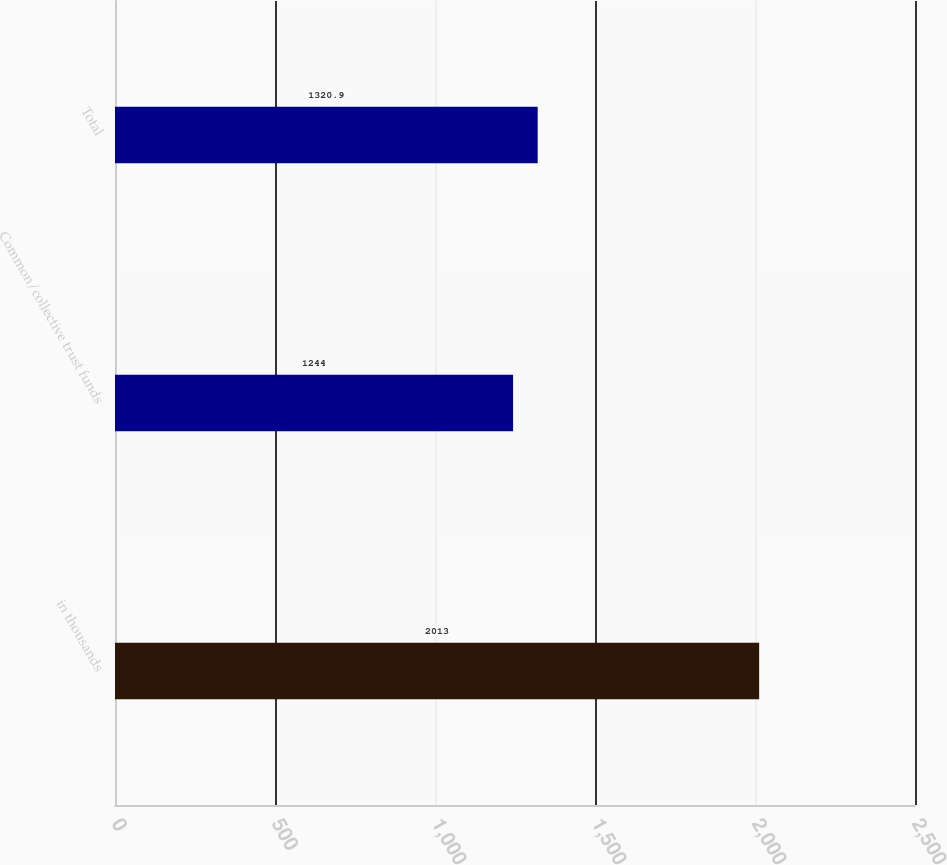<chart> <loc_0><loc_0><loc_500><loc_500><bar_chart><fcel>in thousands<fcel>Common/collective trust funds<fcel>Total<nl><fcel>2013<fcel>1244<fcel>1320.9<nl></chart> 